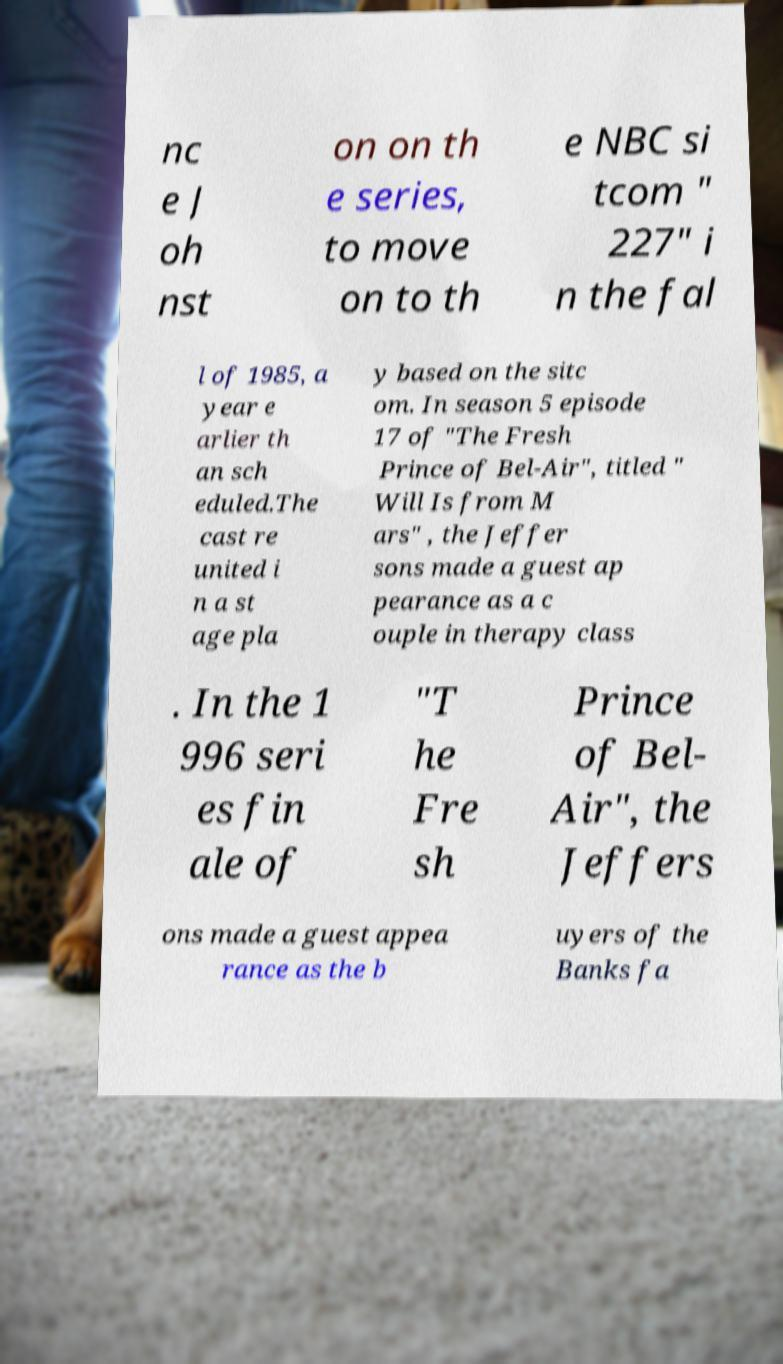Could you extract and type out the text from this image? nc e J oh nst on on th e series, to move on to th e NBC si tcom " 227" i n the fal l of 1985, a year e arlier th an sch eduled.The cast re united i n a st age pla y based on the sitc om. In season 5 episode 17 of "The Fresh Prince of Bel-Air", titled " Will Is from M ars" , the Jeffer sons made a guest ap pearance as a c ouple in therapy class . In the 1 996 seri es fin ale of "T he Fre sh Prince of Bel- Air", the Jeffers ons made a guest appea rance as the b uyers of the Banks fa 